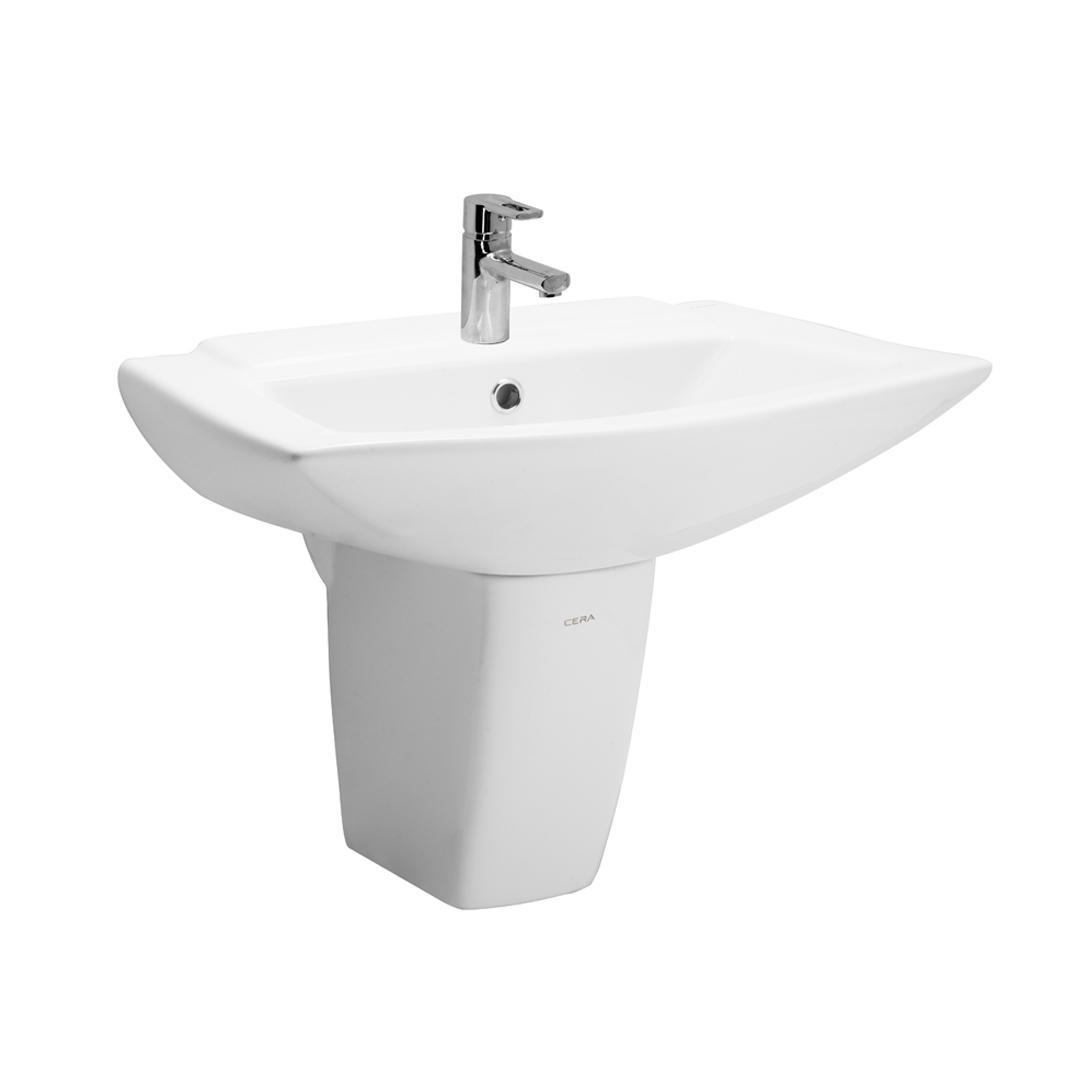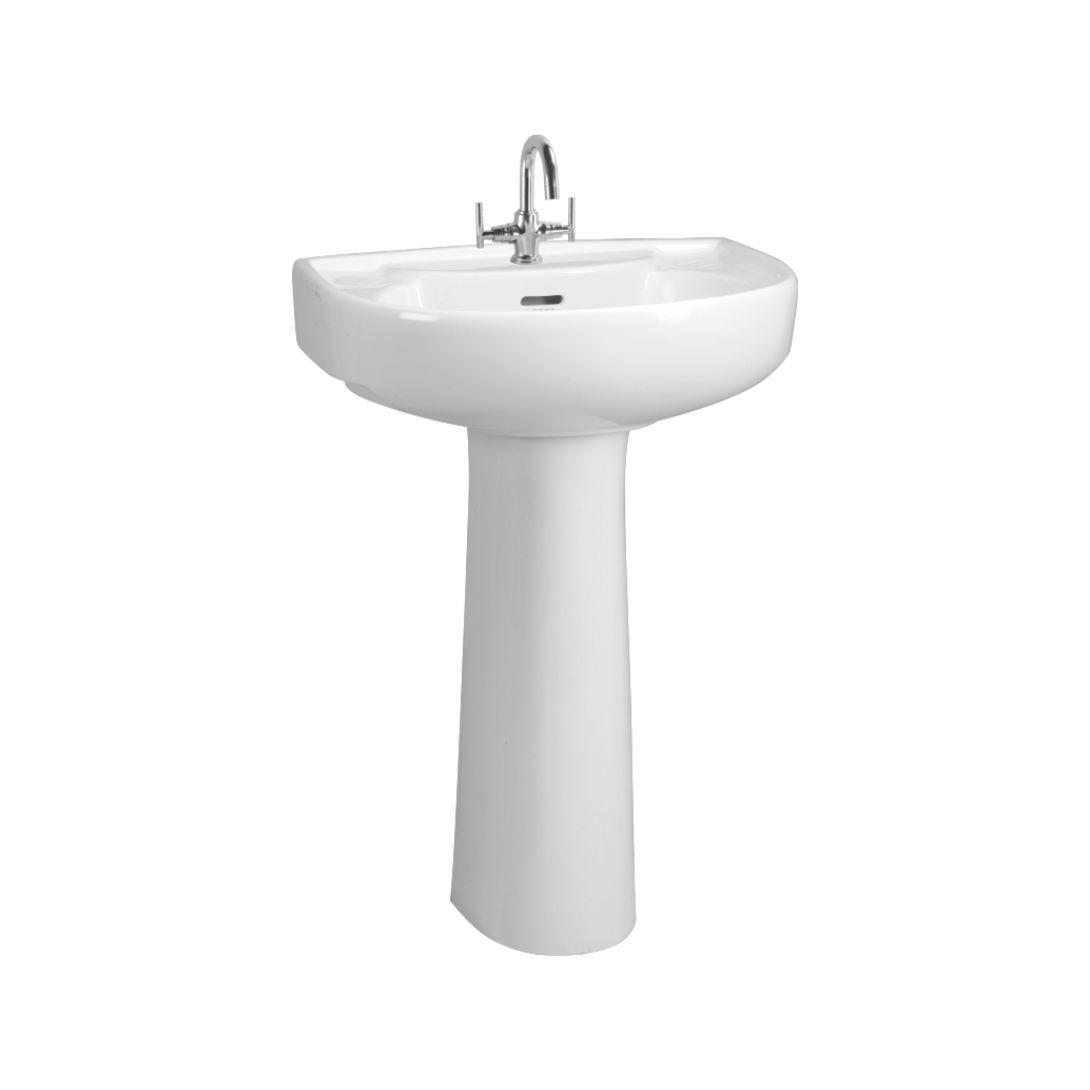The first image is the image on the left, the second image is the image on the right. Examine the images to the left and right. Is the description "One of the sinks is set into a flat counter that is a different color than the sink." accurate? Answer yes or no. No. 